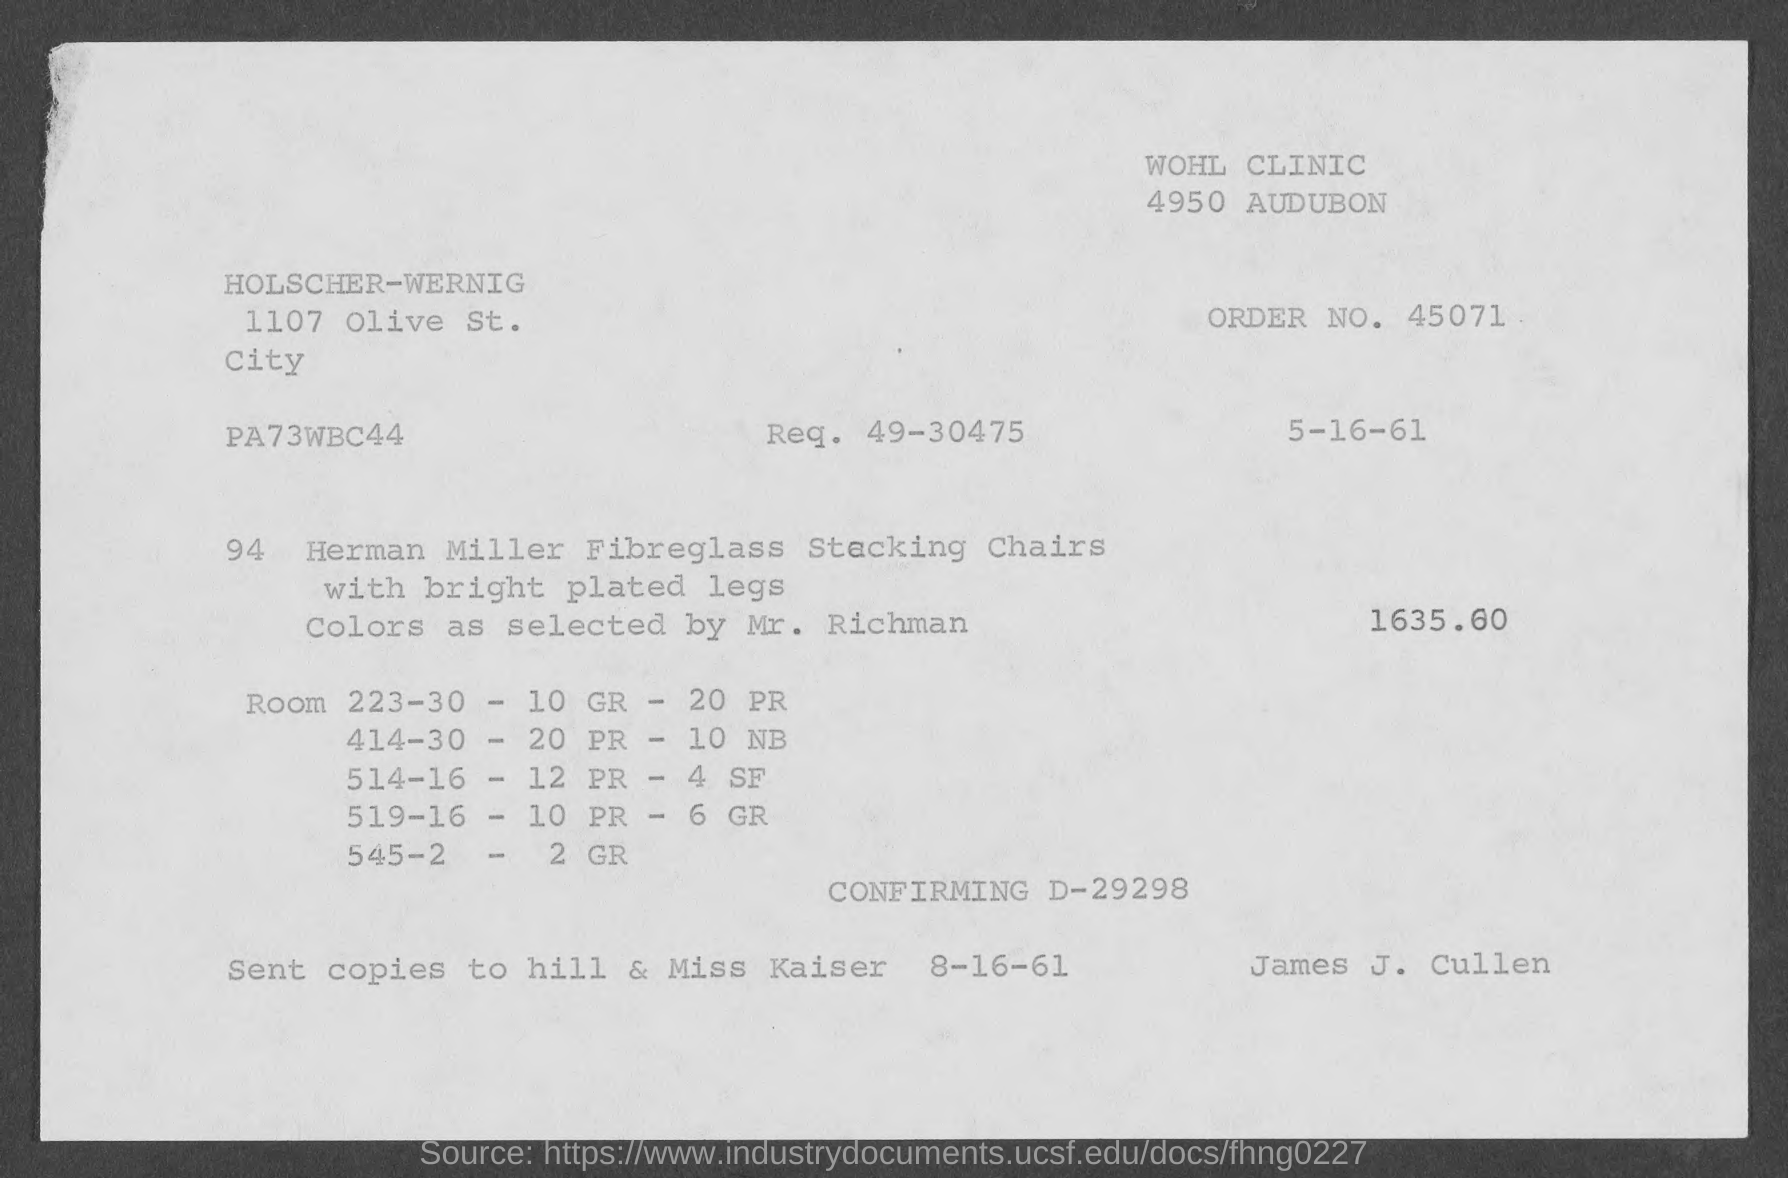What is the order no. mentioned in the given page ?
Provide a short and direct response. 45071. What is the amount mentioned in the given form ?
Give a very brief answer. 1635.60. What is the req. mentioned in the given form ?
Offer a very short reply. 49-30475. 